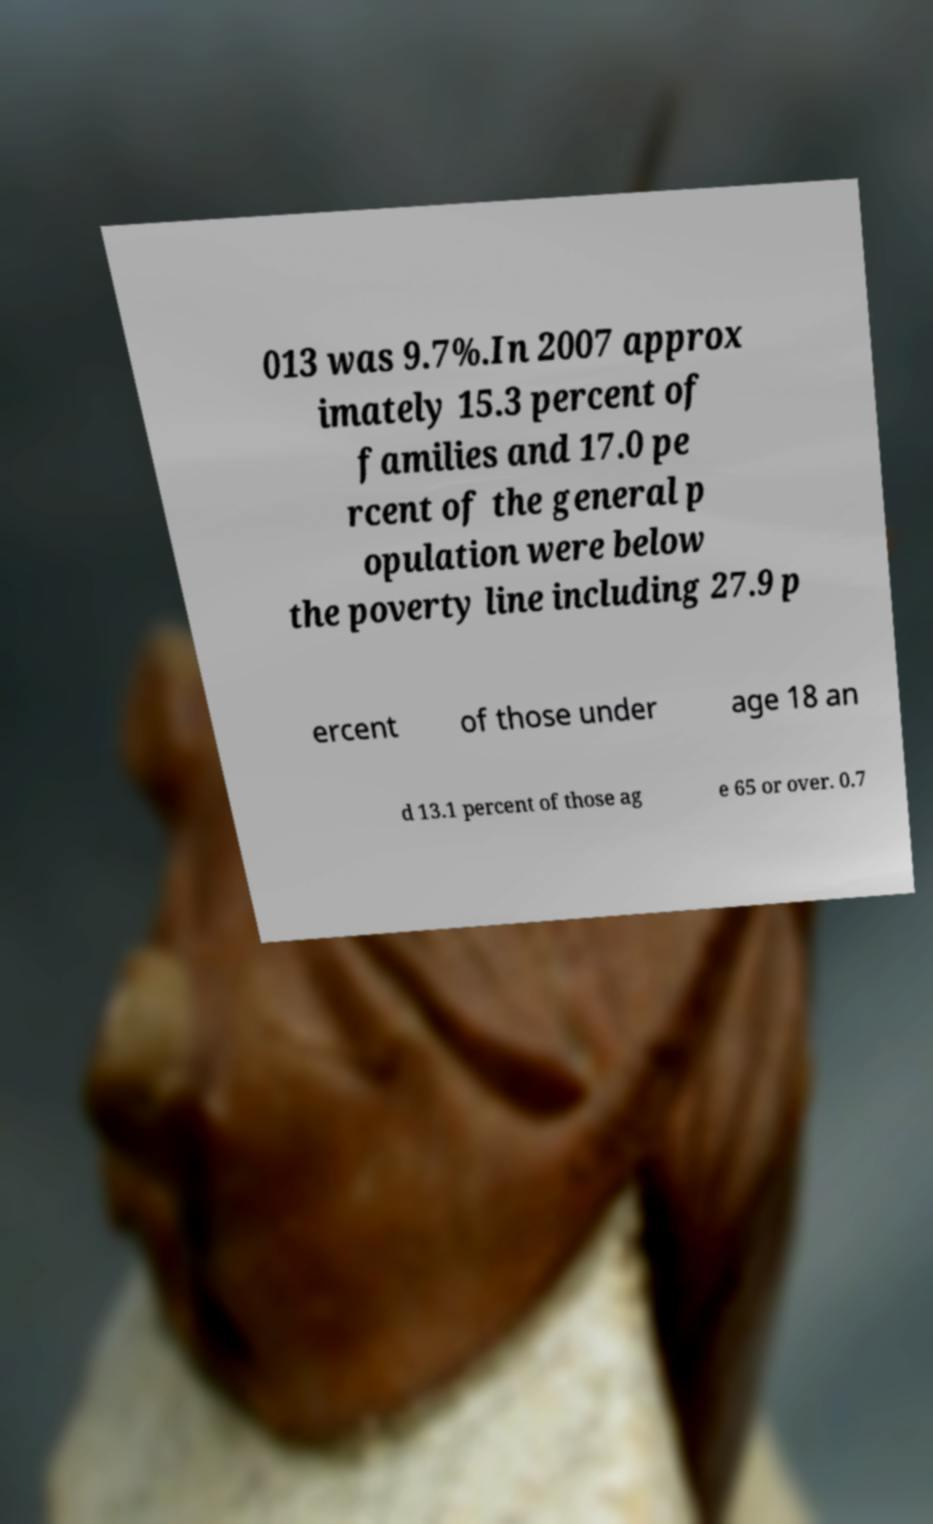Could you extract and type out the text from this image? 013 was 9.7%.In 2007 approx imately 15.3 percent of families and 17.0 pe rcent of the general p opulation were below the poverty line including 27.9 p ercent of those under age 18 an d 13.1 percent of those ag e 65 or over. 0.7 